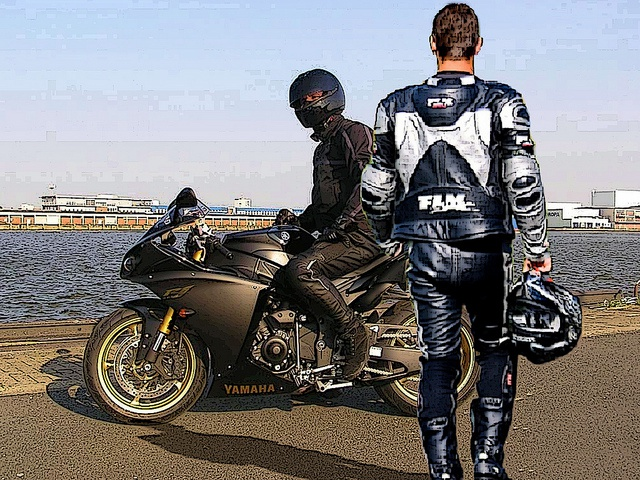Describe the objects in this image and their specific colors. I can see motorcycle in lavender, black, and gray tones, people in lavender, black, white, gray, and darkgray tones, and people in lavender, black, and gray tones in this image. 